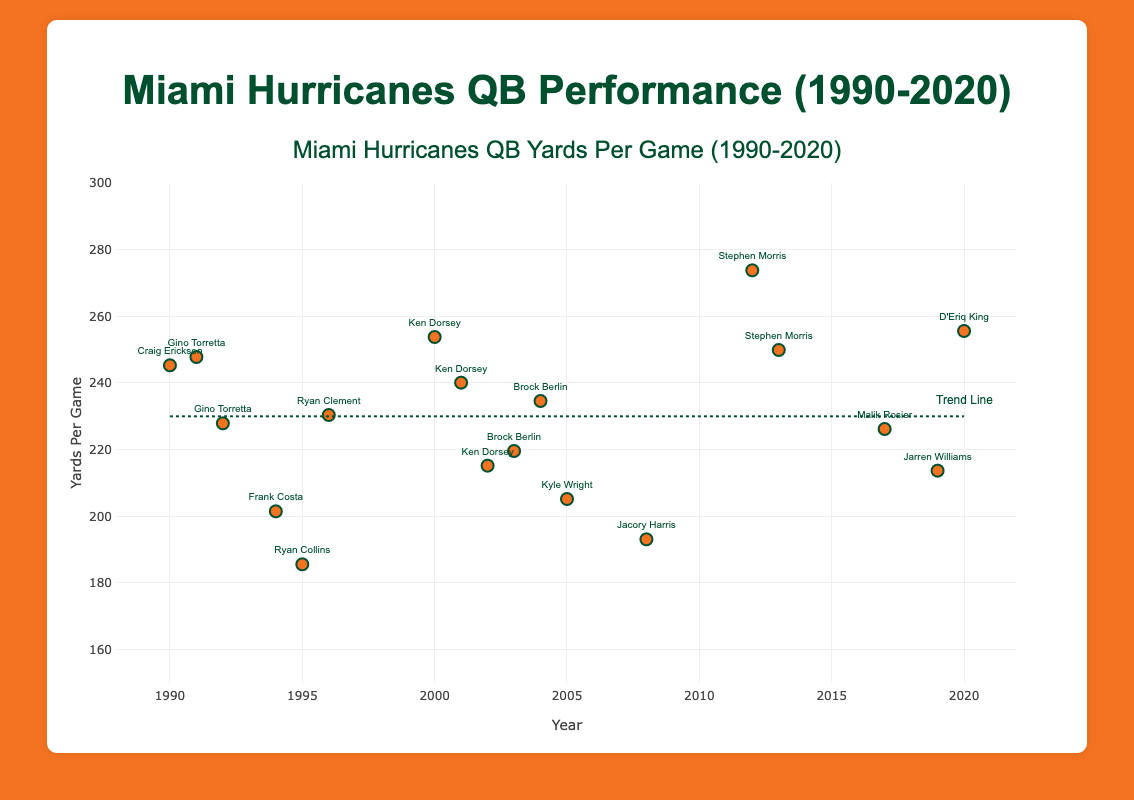How many different quarterbacks are represented in the plot? By looking at the scatter plot, each marker has a text label indicating the quarterback. Counting each unique name among the labels will give the number of different quarterbacks.
Answer: 12 What is the range of years shown in the plot? The x-axis represents the years, with the first year being 1990 and the last year being 2020.
Answer: 1990-2020 Which year did the Miami Hurricanes quarterback have the highest yards per game? By scanning the y-axis for the highest point on the plot and checking the corresponding year, one can find which year had the highest yards per game.
Answer: 2012 Who was the quarterback in 1995, and how many yards per game did they achieve? Finding the marker for the year 1995 and reading the text label will reveal the quarterback, and the y-value will provide the yards per game.
Answer: Ryan Collins, 185.6 What is the trend line's approximate value in the year 2000? Observing the trend line, find where it intersects with the year 2000 on the x-axis, then read the corresponding y-value.
Answer: Approximately 230 Between which years did Ken Dorsey play, and what was his highest yards per game? Locate the markers labeled 'Ken Dorsey' to determine the years he played, and compare his yards per game values to identify the highest one.
Answer: 2000-2002, 253.8 How does the yards per game of Gino Torretta in 1991 compare to his performance in 1992? Find the markers for 1991 and 1992 labeled 'Gino Torretta' and compare the respective y-values for each year.
Answer: Higher in 1991 Which quarterback had the lowest yards per game, and what was the value? Identify the marker corresponding to the lowest point on the y-axis, then check the text label for the quarterback's name and read the y-value for the yards per game.
Answer: Ryan Collins, 185.6 What is the average yards per game for the quarterbacks in the years 2000, 2001, and 2002? Sum the yards per game for these years (253.8, 240.1, 215.2) and divide by 3 to find the average.
Answer: 236.37 Did the Miami Hurricanes' quarterbacks' performance generally improve, decline, or stay constant over the years? Observe the overall direction of the trend line from 1990 to 2020 to determine the general trend.
Answer: Fluctuated 